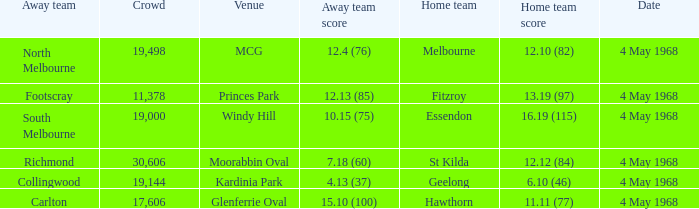What home team played at MCG? North Melbourne. 